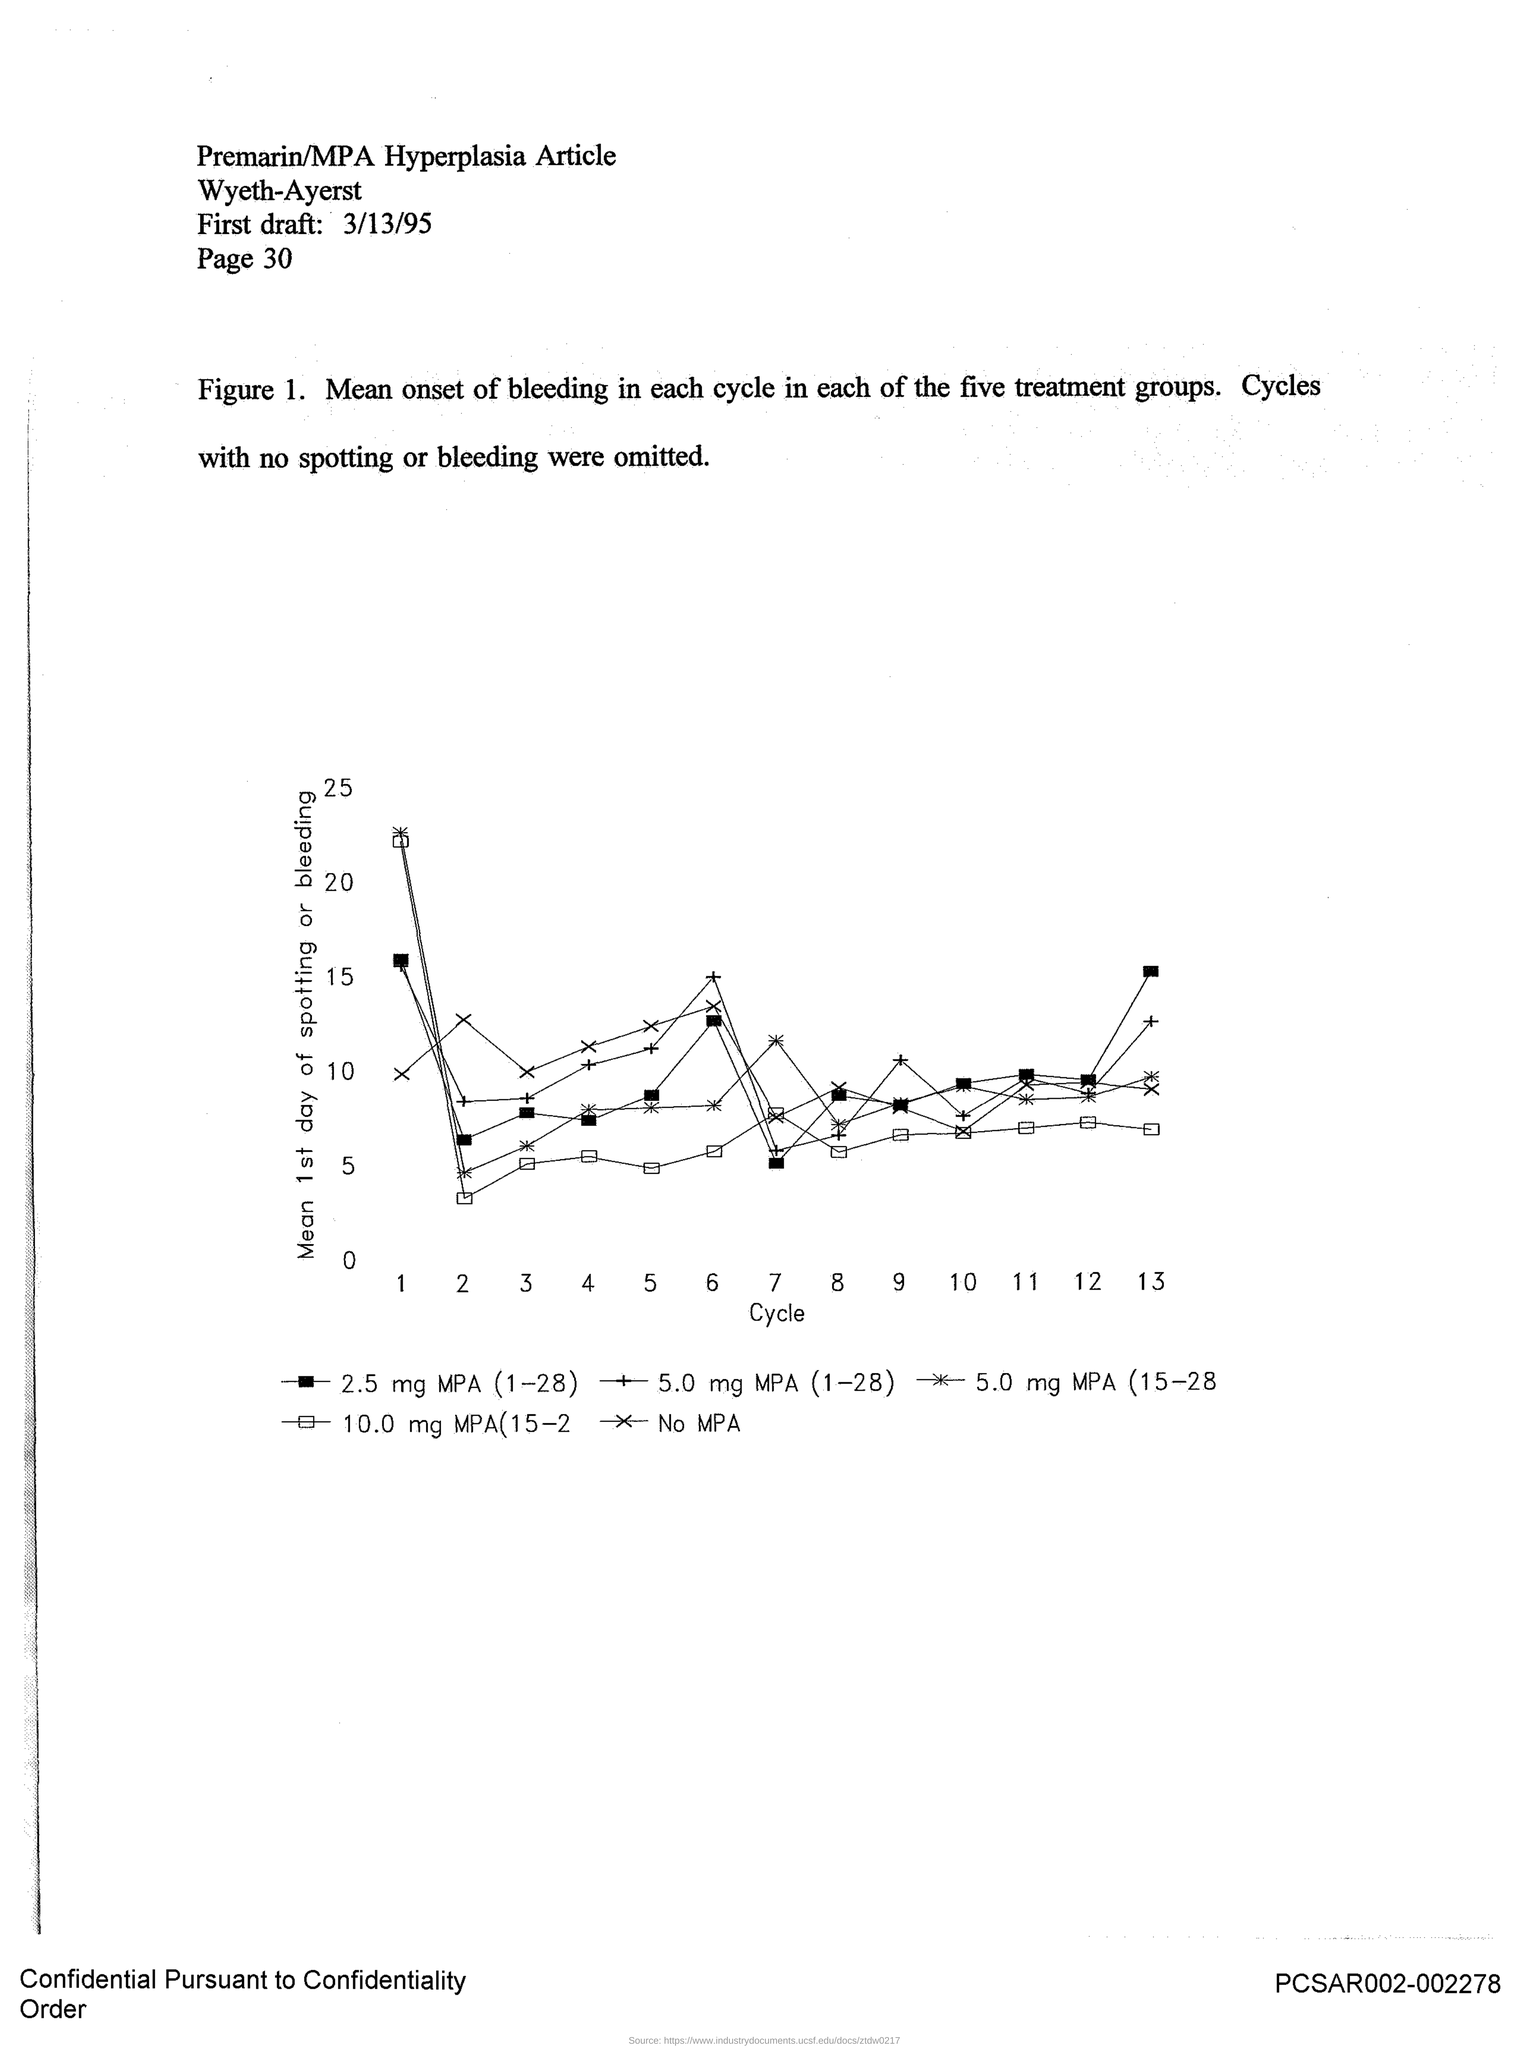What is plotted in the x-axis ?
Provide a succinct answer. Cycle. What is plotted in the y-axis?
Provide a succinct answer. Mean 1st day of spotting or bleeding. 